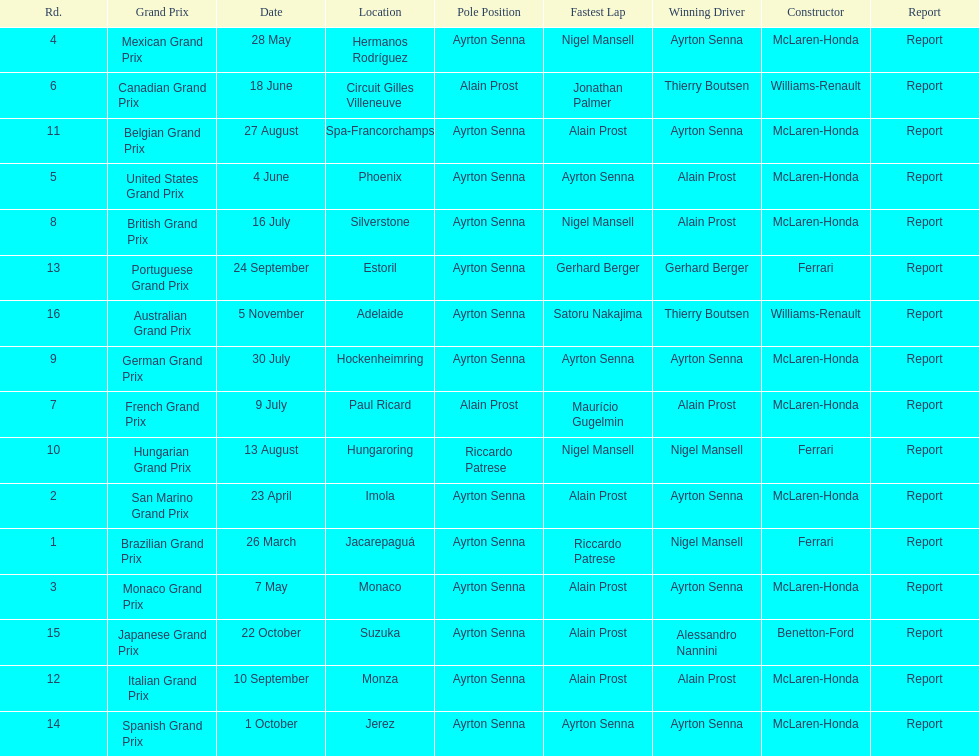How many did alain prost have the fastest lap? 5. 